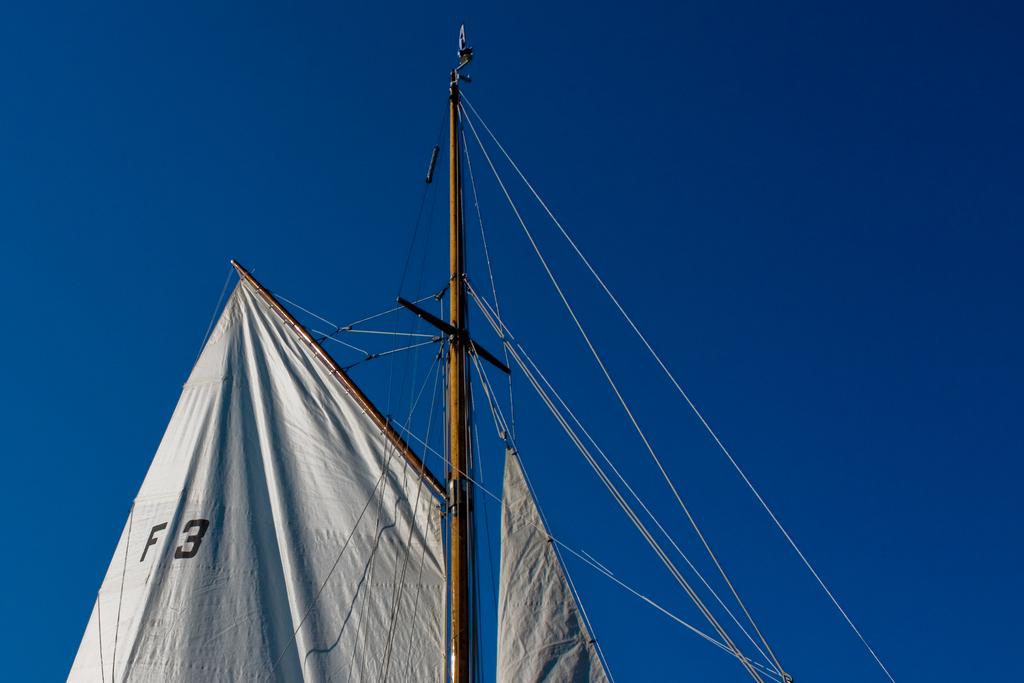What is on the sail?
Give a very brief answer. F3. What is the number and letter on the boat?
Ensure brevity in your answer.  F3. 